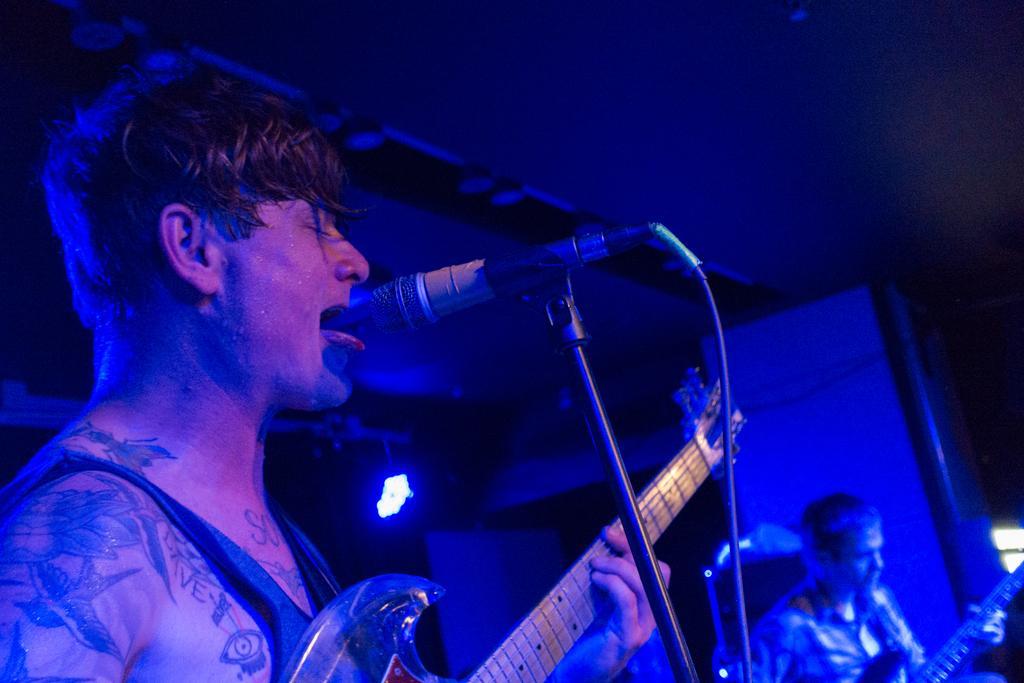In one or two sentences, can you explain what this image depicts? This image is taken in a concert. At the top of the image there is a ceiling. In the background there is a wall and there is a light. On the left side of the image a man is standing and he is holding a guitar in his hands. He is playing music and singing. On the right side of the image there is another man standing and holding a guitar in his hands. 